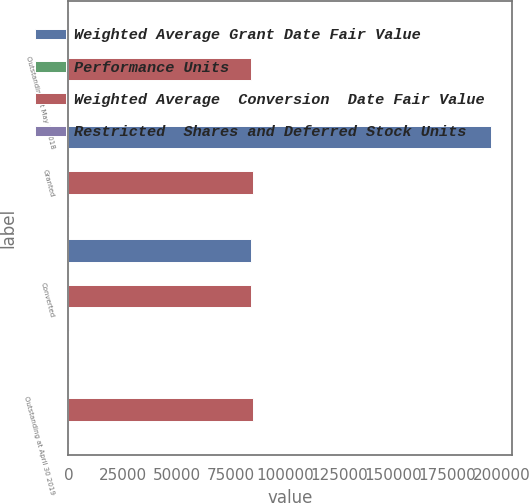Convert chart. <chart><loc_0><loc_0><loc_500><loc_500><stacked_bar_chart><ecel><fcel>Outstanding at May 1 2018<fcel>Granted<fcel>Converted<fcel>Outstanding at April 30 2019<nl><fcel>Weighted Average Grant Date Fair Value<fcel>123.68<fcel>194932<fcel>84051<fcel>123.68<nl><fcel>Performance Units<fcel>122.39<fcel>104.33<fcel>103.86<fcel>118.44<nl><fcel>Weighted Average  Conversion  Date Fair Value<fcel>84051<fcel>85154<fcel>84051<fcel>85154<nl><fcel>Restricted  Shares and Deferred Stock Units<fcel>103.86<fcel>123.68<fcel>103.86<fcel>123.68<nl></chart> 